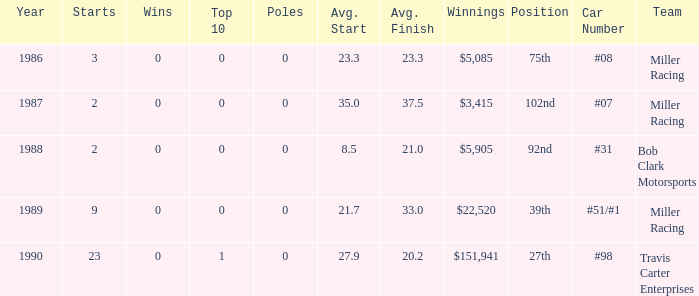What are the poles is #08 Miller racing? 0.0. 